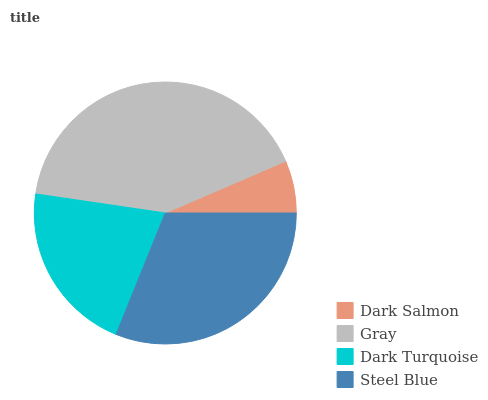Is Dark Salmon the minimum?
Answer yes or no. Yes. Is Gray the maximum?
Answer yes or no. Yes. Is Dark Turquoise the minimum?
Answer yes or no. No. Is Dark Turquoise the maximum?
Answer yes or no. No. Is Gray greater than Dark Turquoise?
Answer yes or no. Yes. Is Dark Turquoise less than Gray?
Answer yes or no. Yes. Is Dark Turquoise greater than Gray?
Answer yes or no. No. Is Gray less than Dark Turquoise?
Answer yes or no. No. Is Steel Blue the high median?
Answer yes or no. Yes. Is Dark Turquoise the low median?
Answer yes or no. Yes. Is Dark Salmon the high median?
Answer yes or no. No. Is Dark Salmon the low median?
Answer yes or no. No. 